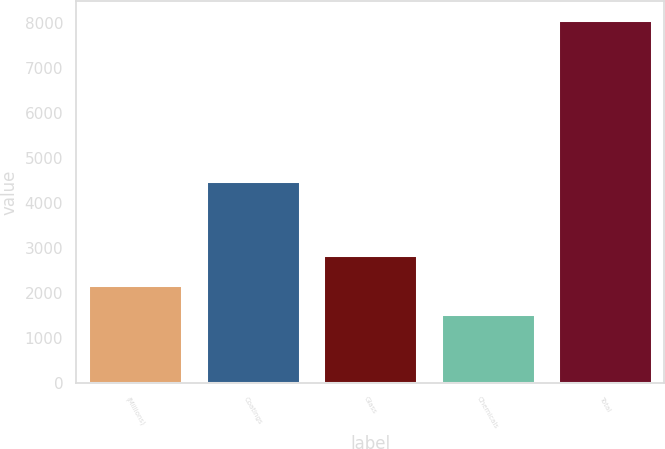Convert chart to OTSL. <chart><loc_0><loc_0><loc_500><loc_500><bar_chart><fcel>(Millions)<fcel>Coatings<fcel>Glass<fcel>Chemicals<fcel>Total<nl><fcel>2169.3<fcel>4482<fcel>2824.6<fcel>1514<fcel>8067<nl></chart> 